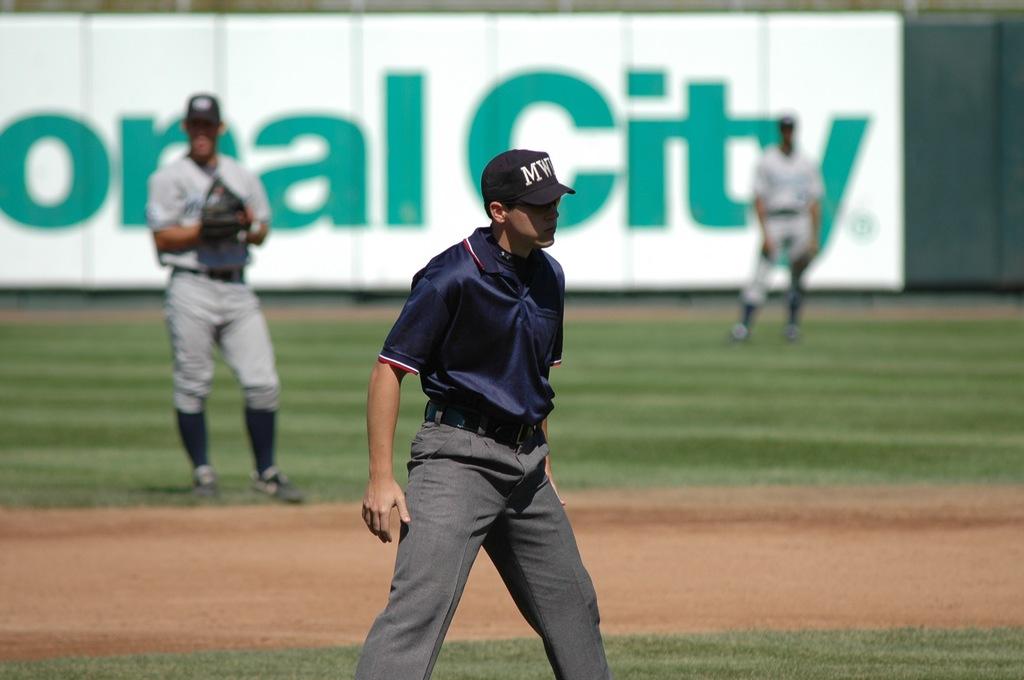Does the sign say city on it?
Provide a succinct answer. Yes. What letters are on the baseball cap?
Your answer should be very brief. Mw. 